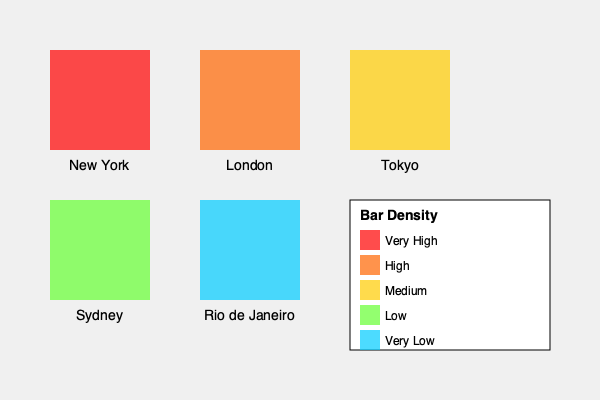Given the heat map of bar density in different global cities, calculate the probability that a randomly selected city from this dataset has a bar density classified as "High" or "Very High". Additionally, if you were to visit two of these cities at random, what is the probability that at least one of them would have a "Medium" or higher bar density? Let's approach this step-by-step:

1) First, let's count the number of cities in each category:
   Very High: 1 (New York)
   High: 1 (London)
   Medium: 1 (Tokyo)
   Low: 1 (Sydney)
   Very Low: 1 (Rio de Janeiro)
   Total cities: 5

2) For the first part of the question:
   P(High or Very High) = (Number of High + Very High) / Total cities
                        = (1 + 1) / 5 = 2/5 = 0.4 or 40%

3) For the second part, we need to calculate the probability of selecting at least one city with "Medium" or higher density out of two randomly selected cities.

   It's easier to calculate the probability of NOT selecting any city with "Medium" or higher density, and then subtract this from 1.

4) P(No Medium or higher in 2 selections) = P(Low or Very Low) * P(Low or Very Low)
                                          = (2/5) * (1/4) = 1/10 = 0.1 or 10%

5) Therefore, P(At least one Medium or higher in 2 selections) = 1 - P(No Medium or higher in 2 selections)
                                                               = 1 - 0.1 = 0.9 or 90%
Answer: 0.4; 0.9 